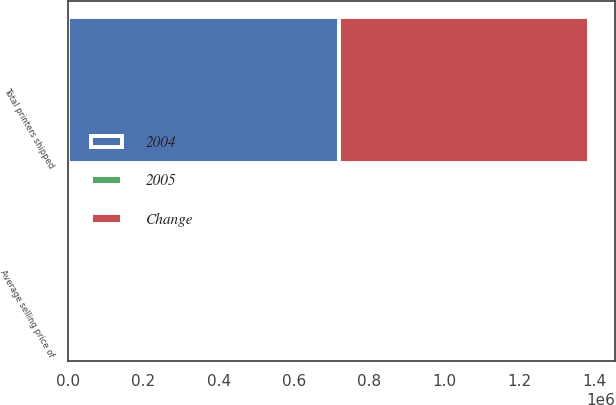Convert chart to OTSL. <chart><loc_0><loc_0><loc_500><loc_500><stacked_bar_chart><ecel><fcel>Total printers shipped<fcel>Average selling price of<nl><fcel>2004<fcel>719576<fcel>629<nl><fcel>Change<fcel>667044<fcel>646<nl><fcel>2005<fcel>7.9<fcel>2.6<nl></chart> 